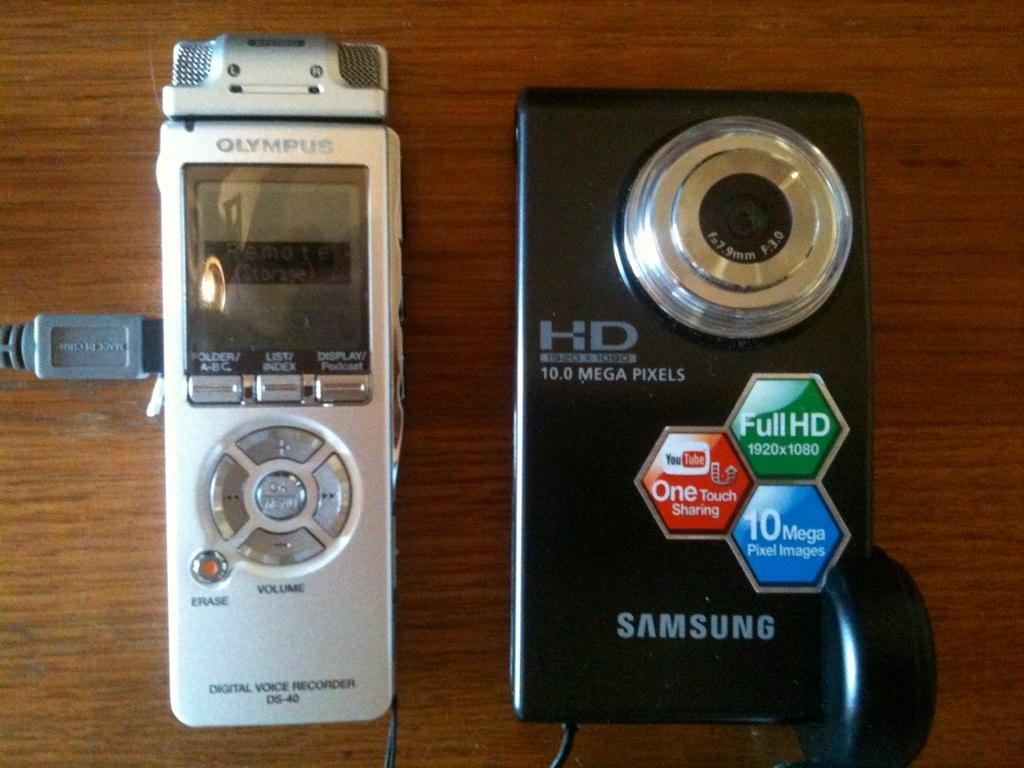Provide a one-sentence caption for the provided image. A silver Olympus digital voice recorder sitting next to a black Samsung HD camera on a table. 